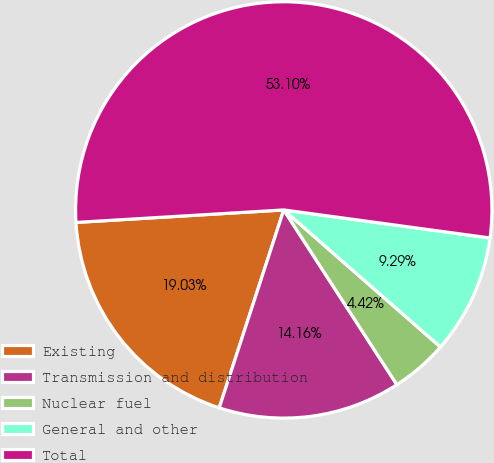Convert chart to OTSL. <chart><loc_0><loc_0><loc_500><loc_500><pie_chart><fcel>Existing<fcel>Transmission and distribution<fcel>Nuclear fuel<fcel>General and other<fcel>Total<nl><fcel>19.03%<fcel>14.16%<fcel>4.42%<fcel>9.29%<fcel>53.11%<nl></chart> 